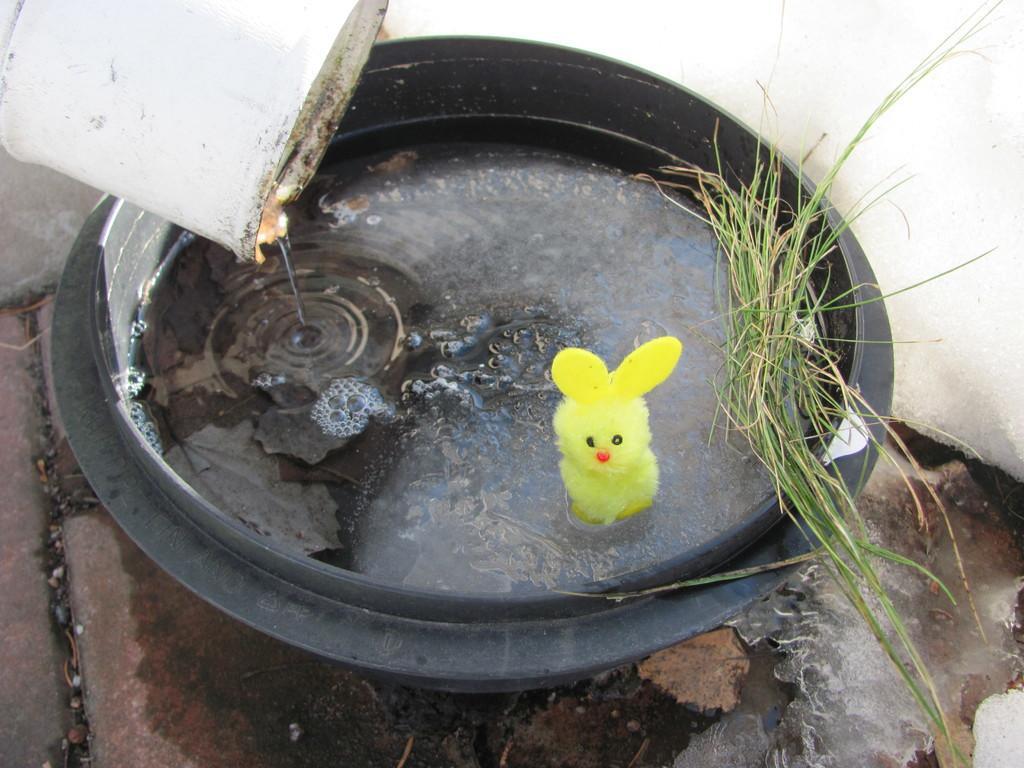Please provide a concise description of this image. In this picture there is a water tub in the center of the image, in which there is a toy and there is grass in the bottom right side of the image, it seems to be there is a bucket in the top left side of the image. 